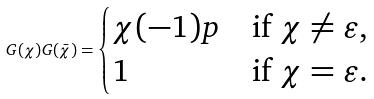Convert formula to latex. <formula><loc_0><loc_0><loc_500><loc_500>G ( \chi ) G ( \bar { \chi } ) = \begin{cases} \chi ( - 1 ) p & \text {if } \chi \neq \varepsilon , \\ 1 & \text {if } \chi = \varepsilon . \end{cases}</formula> 